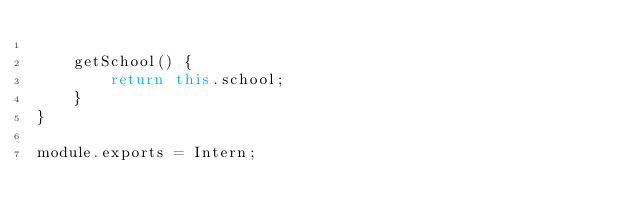<code> <loc_0><loc_0><loc_500><loc_500><_JavaScript_>
    getSchool() {
        return this.school;
    }
}

module.exports = Intern;</code> 